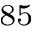Convert formula to latex. <formula><loc_0><loc_0><loc_500><loc_500>^ { 8 5 }</formula> 